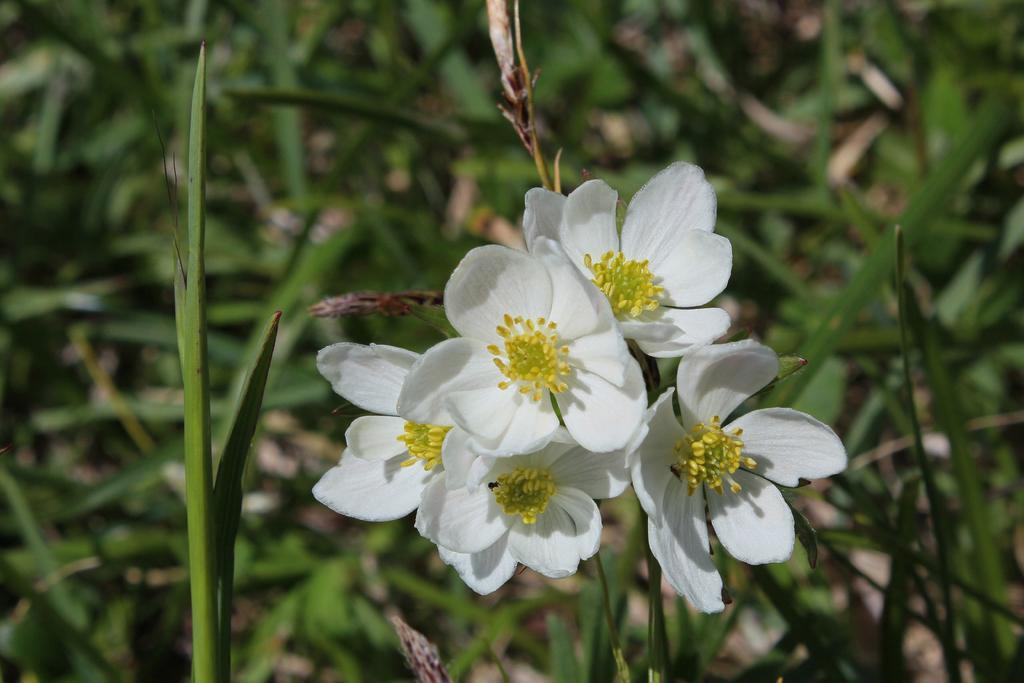Could you give a brief overview of what you see in this image? As we can see in the image there are plants and white color flowers. 